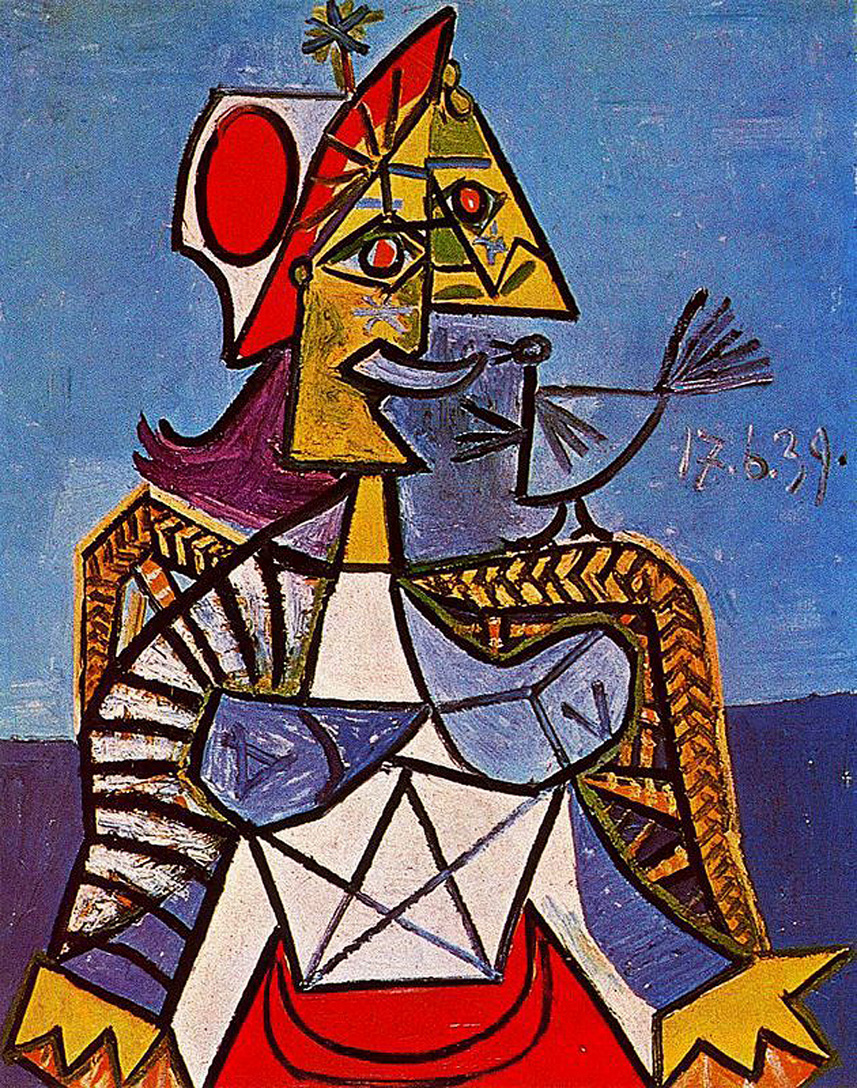What do you see happening in this image? The image showcases a captivating piece of Cubist art. At the center is a figure that has been abstracted into geometric shapes, characteristic of the Cubist style. The figure's head, which is triangular, is adorned with a colorful crown, suggesting a suggestion of royalty or authority. The figure’s face is an interplay of contrasts, with one side in yellow tones and the other in blue, creating a striking effect. It holds an intriguing, stylized bird, which might symbolize freedom or peace.

The artist uses vibrant colors such as yellows, reds, and whites, especially on the figure, creating a vivid contrast with the deep blue and muted background. This intense use of colors highlights the figure and adds depth and complexity to the artwork. Intricate patterns on the figure’s clothing and the dynamic lines give it a sense of movement and vibrancy. The piece is signed and dated '17.6.39,' offering a clue to its historical context and the artist's presence.

Overall, this painting is a thought-provoking example of Cubism, encouraging viewers to interpret the symbolic crowned figure and the delicate bird it holds in their own ways. It’s a harmonious blend of abstraction, geometry, and symbolism, inviting a deeper contemplation of its themes and artistry. 